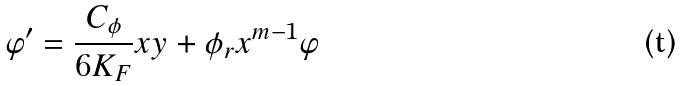<formula> <loc_0><loc_0><loc_500><loc_500>\varphi ^ { \prime } = \frac { C _ { \phi } } { 6 K _ { F } } x y + \phi _ { r } x ^ { m - 1 } \varphi</formula> 